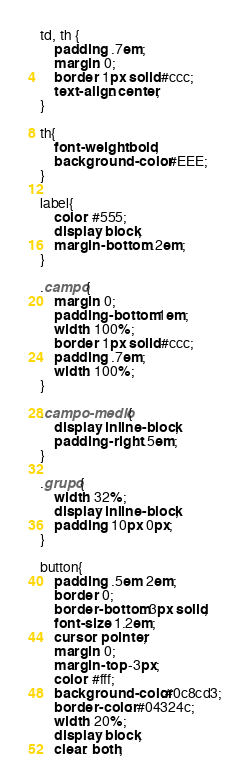<code> <loc_0><loc_0><loc_500><loc_500><_CSS_>
td, th {
	padding: .7em;
	margin: 0;
	border: 1px solid #ccc;
	text-align: center;
}

th{
	font-weight: bold;
	background-color: #EEE;
}

label{
	color: #555;
	display: block;
	margin-bottom: .2em;
}

.campo{
	margin: 0;
	padding-bottom: 1em;
	width: 100%;
	border: 1px solid #ccc;
	padding: .7em;
	width: 100%;
}

.campo-medio{
	display: inline-block;
	padding-right: .5em;
}

.grupo{
	width: 32%;
	display: inline-block;
	padding: 10px 0px;
}

button{
	padding: .5em 2em;
	border: 0;
	border-bottom: 3px solid;
	font-size: 1.2em;
	cursor: pointer;
	margin: 0;
	margin-top: -3px;
	color: #fff;
	background-color:#0c8cd3;
	border-color: #04324c;
	width: 20%;
    display: block;
    clear: both;</code> 